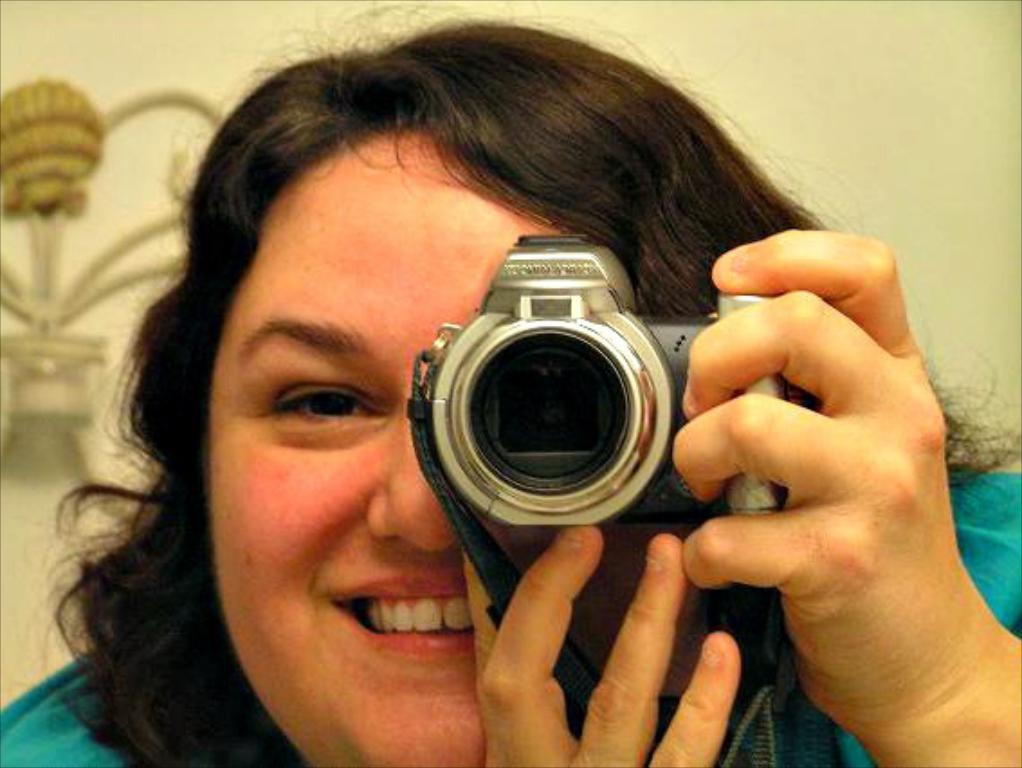Who is the main subject in the image? There is a woman in the image. What is the woman holding in her hand? The woman is holding a camera in her hand. What is the woman's facial expression in the image? The woman is smiling in the image. What can be seen on the wall in the background of the image? There is an object on the wall in the background of the image. How many rabbits are visible in the image? There are no rabbits present in the image. What type of beef is being served at the event in the image? There is no event or beef present in the image; it features a woman holding a camera and smiling. 